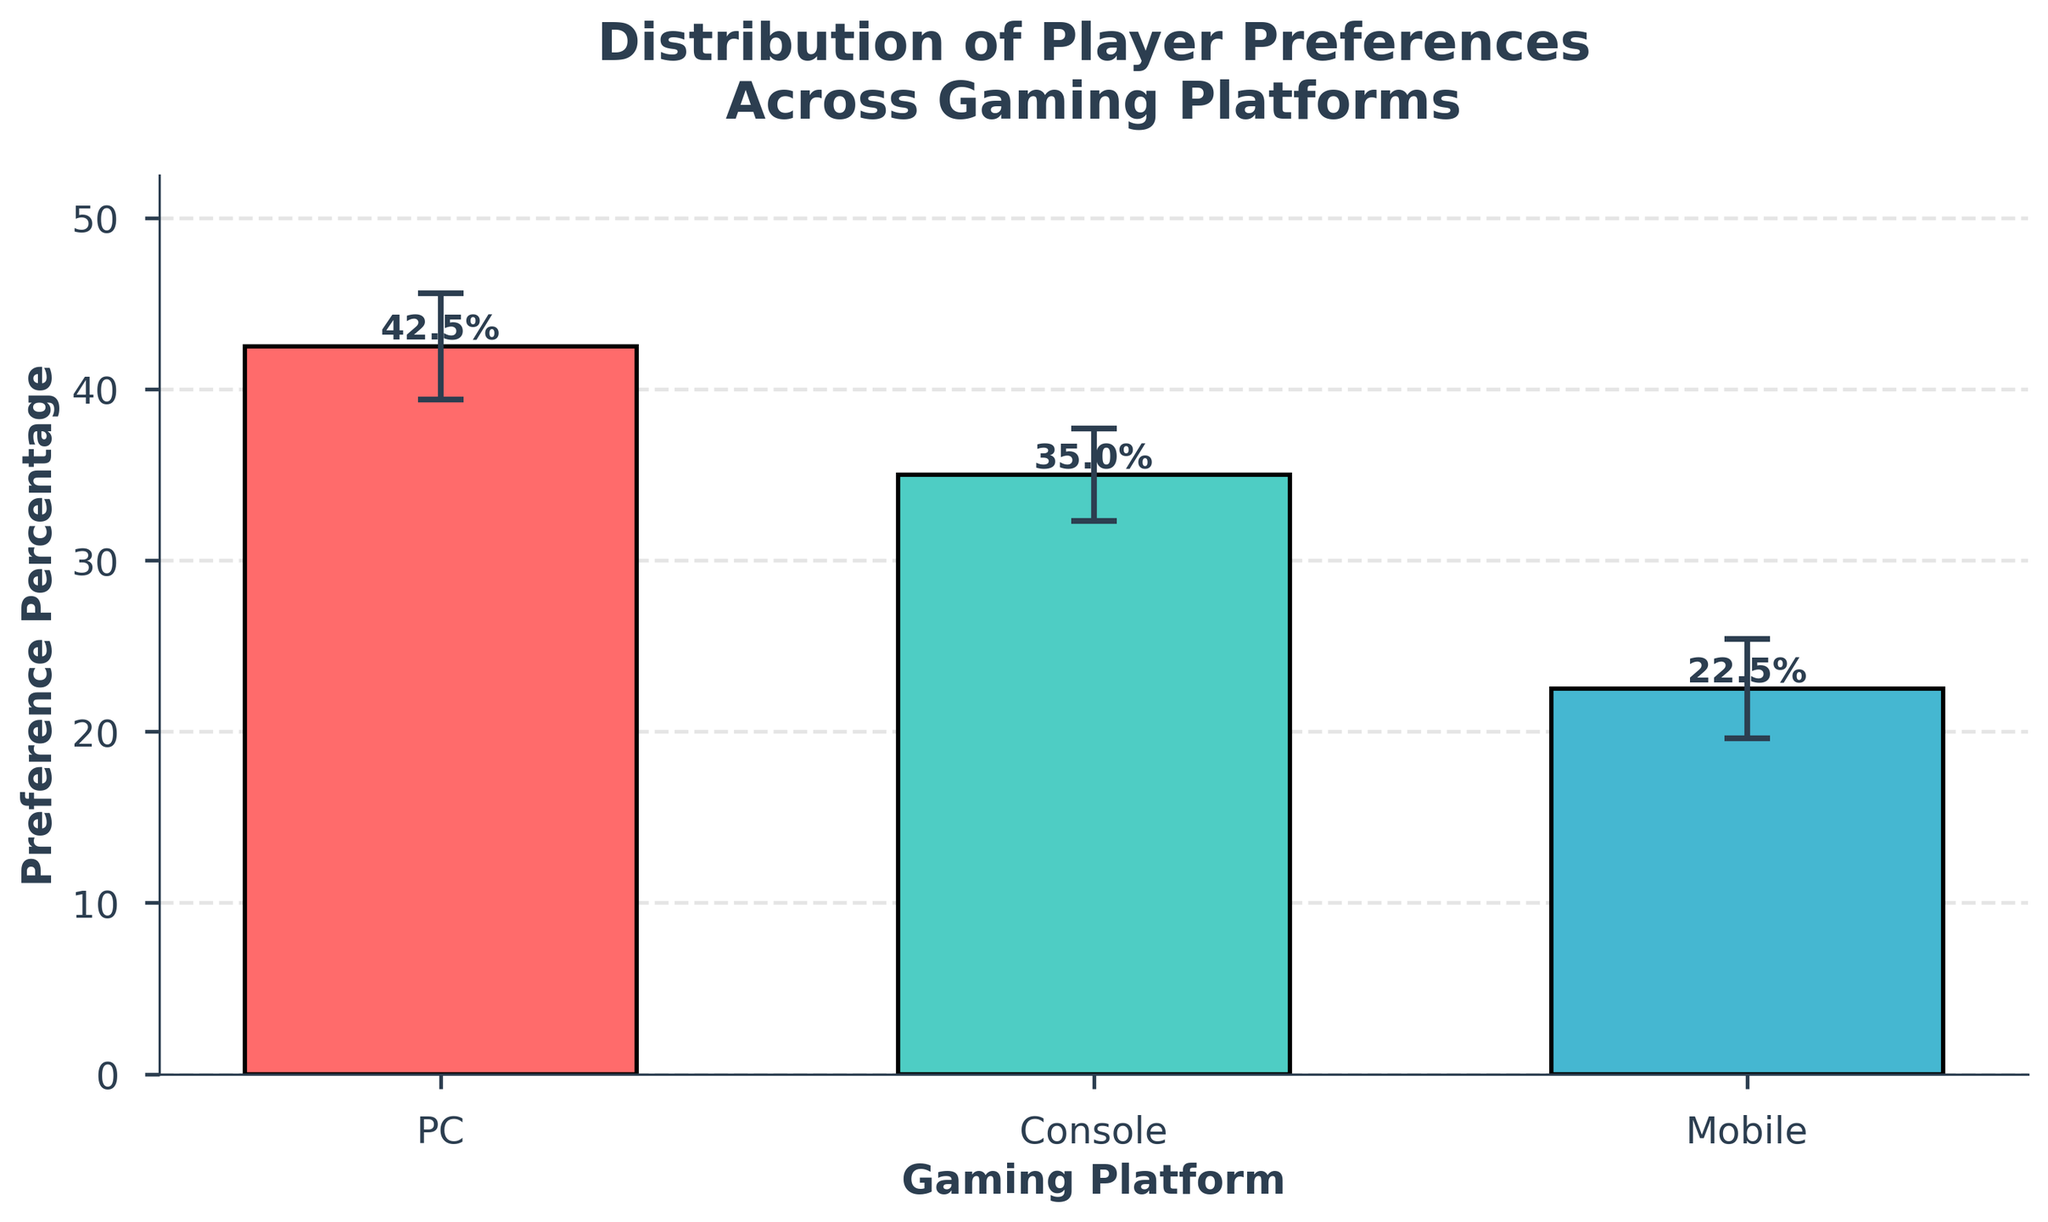What is the title of the bar chart? The title is displayed at the top of the bar chart.
Answer: Distribution of Player Preferences Across Gaming Platforms Which platform has the highest preference percentage? Look at the heights of the bars and identify the tallest one.
Answer: PC What is the preference percentage for the Mobile platform? Read the label at the top of the bar representing the Mobile platform.
Answer: 22.5% What feature is added to indicate variability in the data? Identify the additional graphical elements attached to each bar.
Answer: Error bars What is the sum of preference percentages for PC and Console? Add the percentages for PC and Console (42.5% + 35.0%).
Answer: 77.5% Which platform shows the smallest error bar? Compare the length of the error bars for each platform visually.
Answer: Console How does the preference percentage for Mobile compare to that for Console? Look at the heights of the bars for Mobile and Console, and compare their values.
Answer: Mobile's preference is lower than Console What's the difference in preference percentage between the most and least preferred platforms? Subtract the preference percentage of Mobile from PC (42.5% - 22.5%).
Answer: 20% What are the standard deviations for each platform? Read the error bar values for each platform: PC (3.1), Console (2.7), Mobile (2.9).
Answer: PC: 3.1, Console: 2.7, Mobile: 2.9 Does any platform's error bar overlap with another dataset? Check if the vertical ends of any platform's error bars intersect with any part of a different bar.
Answer: No 